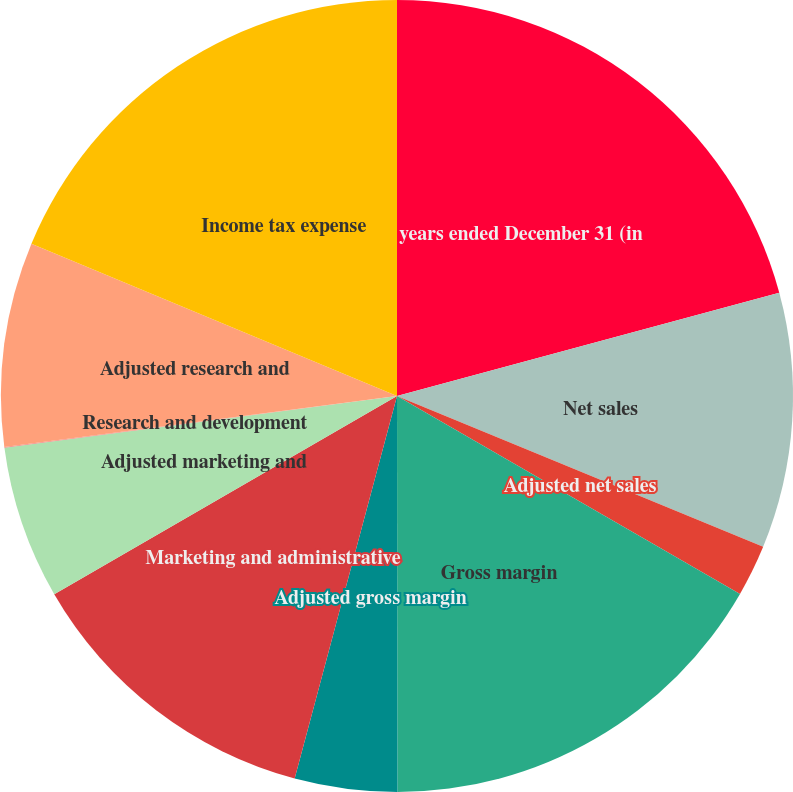<chart> <loc_0><loc_0><loc_500><loc_500><pie_chart><fcel>years ended December 31 (in<fcel>Net sales<fcel>Adjusted net sales<fcel>Gross margin<fcel>Adjusted gross margin<fcel>Marketing and administrative<fcel>Adjusted marketing and<fcel>Research and development<fcel>Adjusted research and<fcel>Income tax expense<nl><fcel>20.8%<fcel>10.42%<fcel>2.11%<fcel>16.65%<fcel>4.18%<fcel>12.49%<fcel>6.26%<fcel>0.03%<fcel>8.34%<fcel>18.72%<nl></chart> 